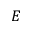<formula> <loc_0><loc_0><loc_500><loc_500>E</formula> 